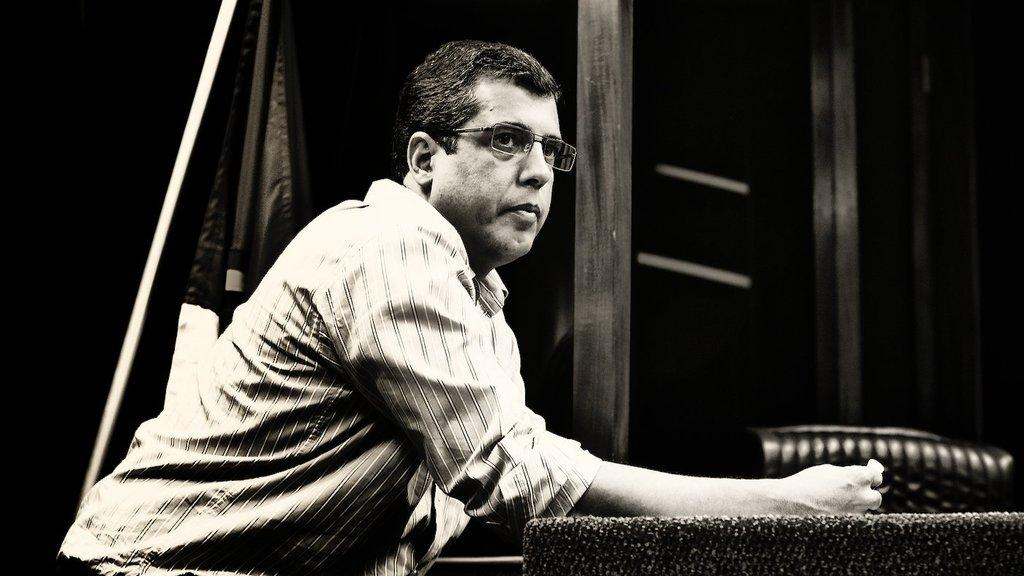What is the main subject of the image? There is a man in the image. What is the man doing in the image? The man is sitting on a chair. Can you describe the man's position in relation to the desk? The man has a hand on the desk. What is the man wearing in the image? The man is wearing a shirt. What other objects can be seen in the image? There are poles visible in the image, and there is a cloth attached to a pole. What type of mine can be seen in the background of the image? There is no mine present in the image; it features a man sitting on a chair with a desk and poles. Are there any bears visible in the image? There are no bears present in the image. 